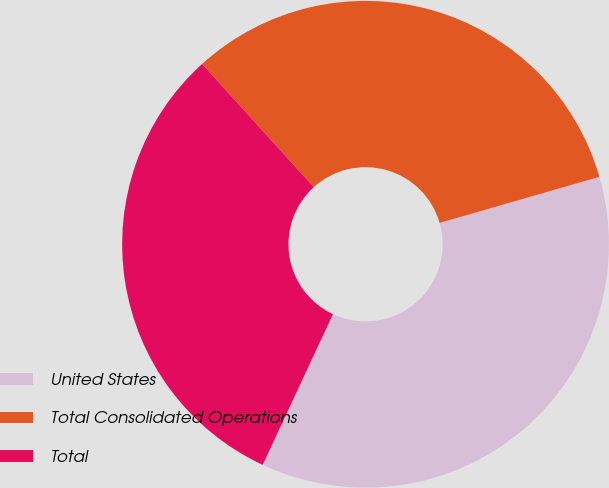Convert chart to OTSL. <chart><loc_0><loc_0><loc_500><loc_500><pie_chart><fcel>United States<fcel>Total Consolidated Operations<fcel>Total<nl><fcel>36.41%<fcel>32.25%<fcel>31.33%<nl></chart> 